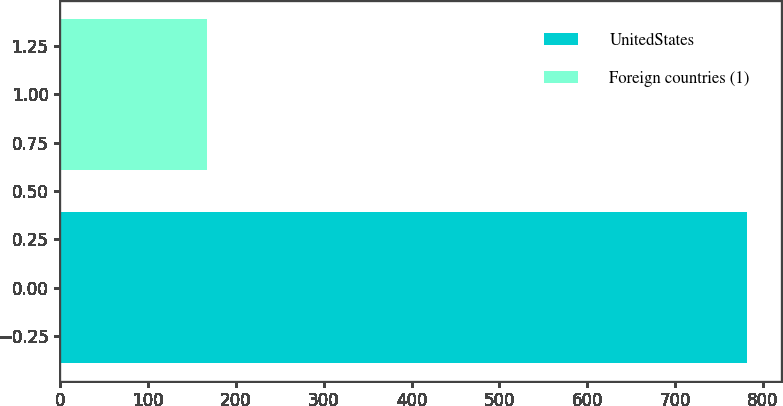<chart> <loc_0><loc_0><loc_500><loc_500><bar_chart><fcel>UnitedStates<fcel>Foreign countries (1)<nl><fcel>782<fcel>167<nl></chart> 